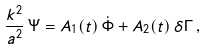Convert formula to latex. <formula><loc_0><loc_0><loc_500><loc_500>\frac { k ^ { 2 } } { a ^ { 2 } } \, \Psi = A _ { 1 } ( t ) \, \dot { \Phi } + A _ { 2 } ( t ) \, \delta \Gamma \, ,</formula> 